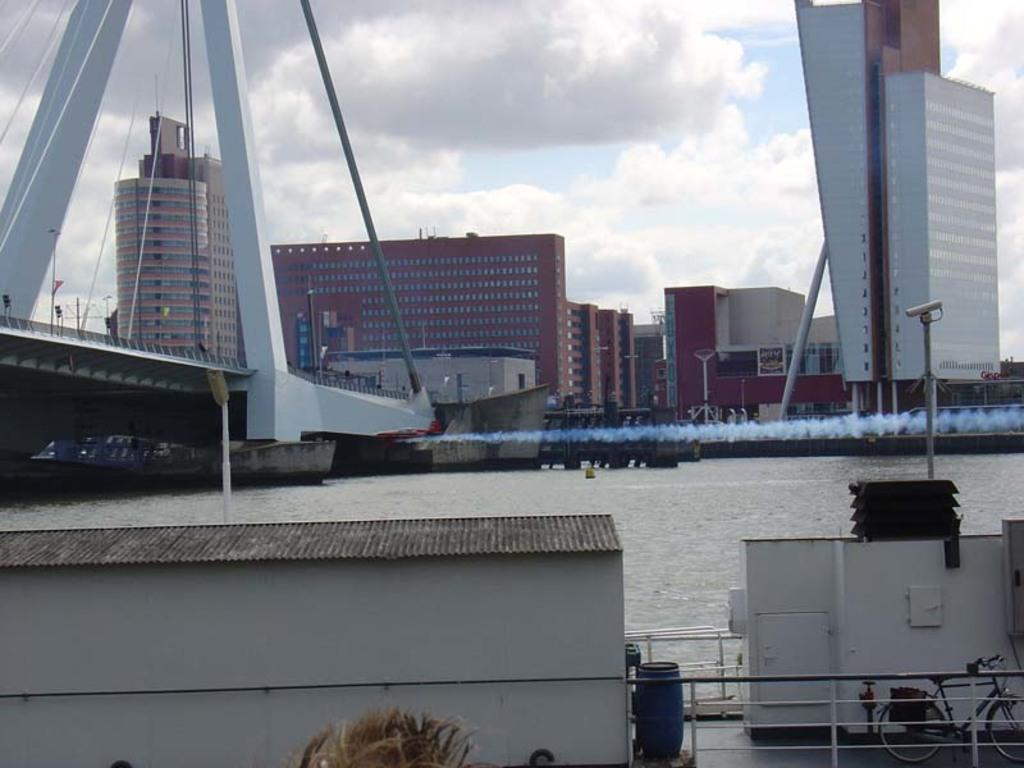What type of natural feature is present in the picture? There is a river in the picture. What type of man-made structures can be seen in the picture? There are buildings in the picture. Where is the bridge located in the picture? The bridge is on the left side of the picture. What is the condition of the sky in the picture? The sky is clear in the picture. Can you tell me how many seeds are visible on the bridge in the image? There are no seeds present on the bridge in the image. What type of cart is being used to transport people across the river in the image? There is no cart present in the image; the bridge is the means of crossing the river. 